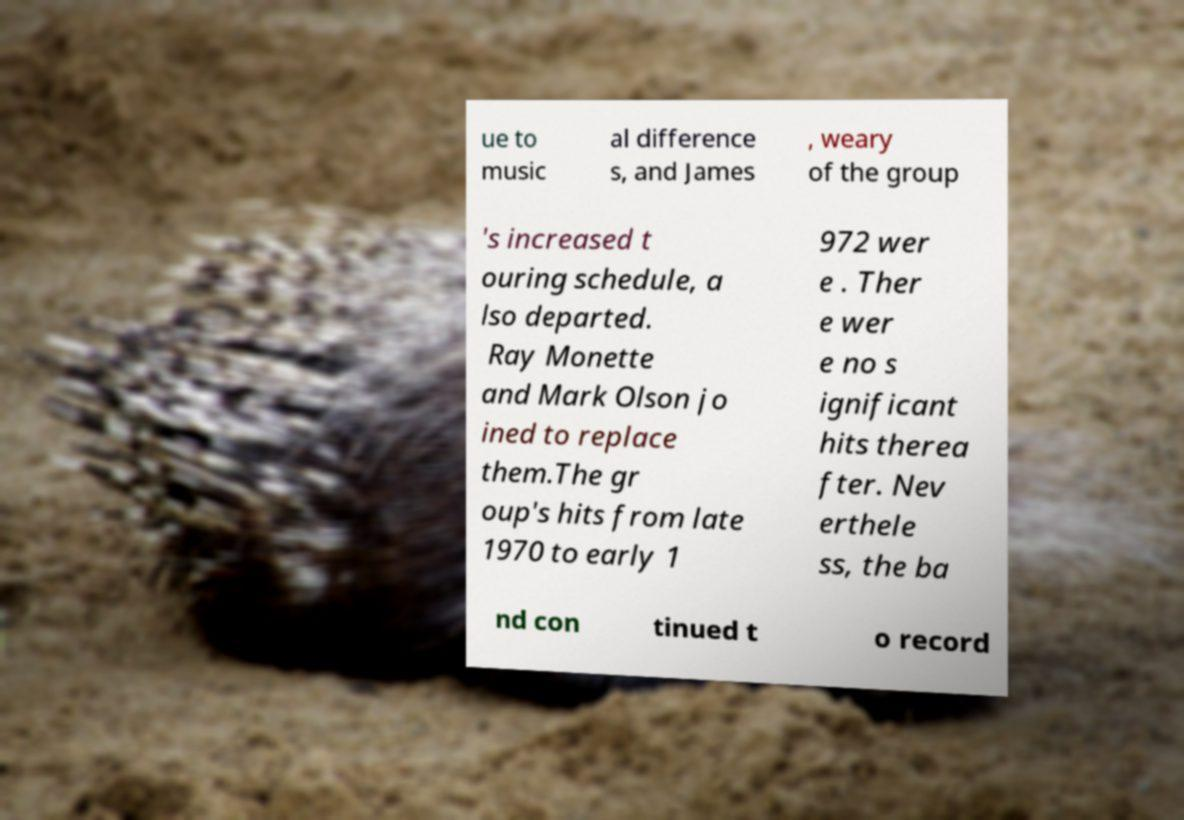What messages or text are displayed in this image? I need them in a readable, typed format. ue to music al difference s, and James , weary of the group 's increased t ouring schedule, a lso departed. Ray Monette and Mark Olson jo ined to replace them.The gr oup's hits from late 1970 to early 1 972 wer e . Ther e wer e no s ignificant hits therea fter. Nev erthele ss, the ba nd con tinued t o record 